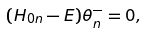<formula> <loc_0><loc_0><loc_500><loc_500>( H _ { 0 n } - E ) \theta ^ { - } _ { n } = 0 ,</formula> 